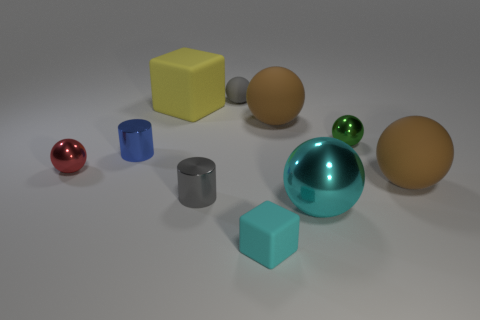Subtract all gray rubber spheres. How many spheres are left? 5 Subtract all red balls. How many balls are left? 5 Subtract all spheres. How many objects are left? 4 Subtract 2 blocks. How many blocks are left? 0 Subtract all gray cylinders. Subtract all gray blocks. How many cylinders are left? 1 Subtract all yellow cubes. How many brown spheres are left? 2 Subtract all tiny gray matte cubes. Subtract all large rubber blocks. How many objects are left? 9 Add 9 gray rubber things. How many gray rubber things are left? 10 Add 1 yellow matte things. How many yellow matte things exist? 2 Subtract 0 gray blocks. How many objects are left? 10 